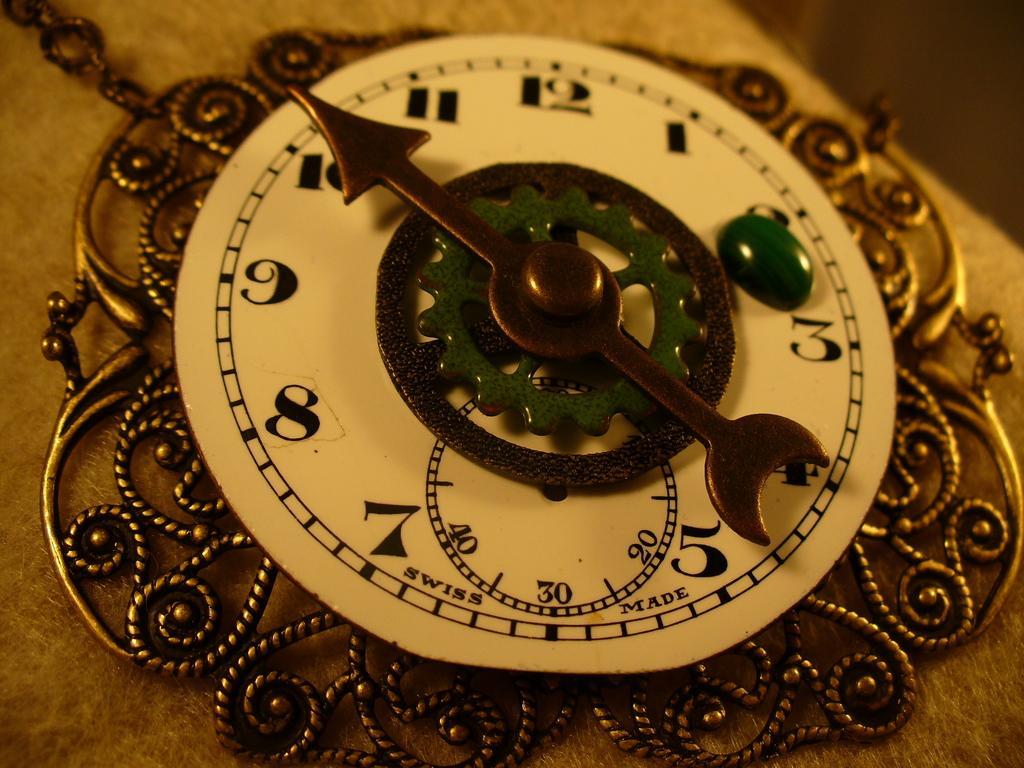Provide a one-sentence caption for the provided image. A swiss pocket watch current time of 10:20. 